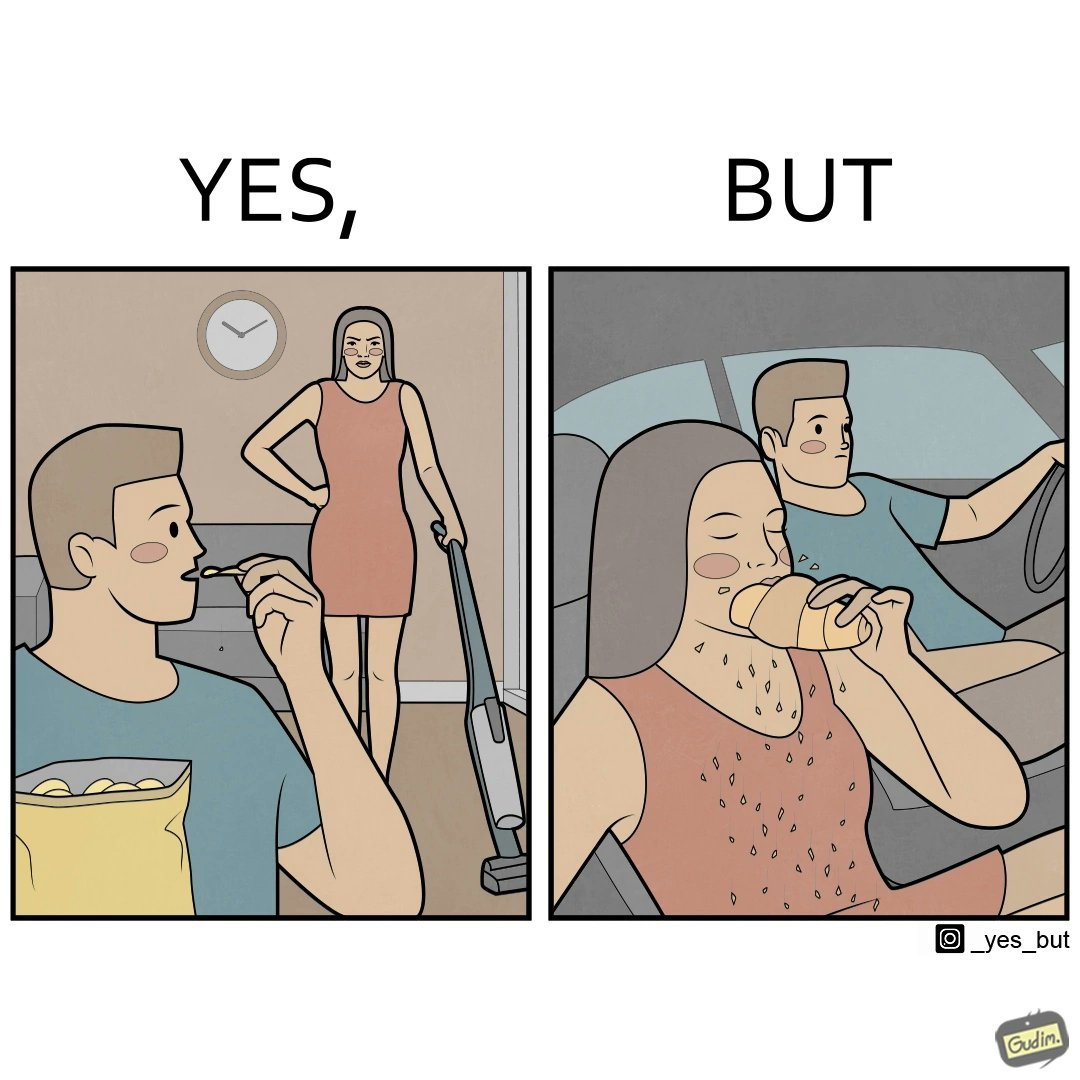Compare the left and right sides of this image. In the left part of the image: a woman cleaning house using vacuum cleaner angrily staring at a man eating chips In the right part of the image: a man looking at the breadcrumbs falling while the woman next to him eating the food while driving car 